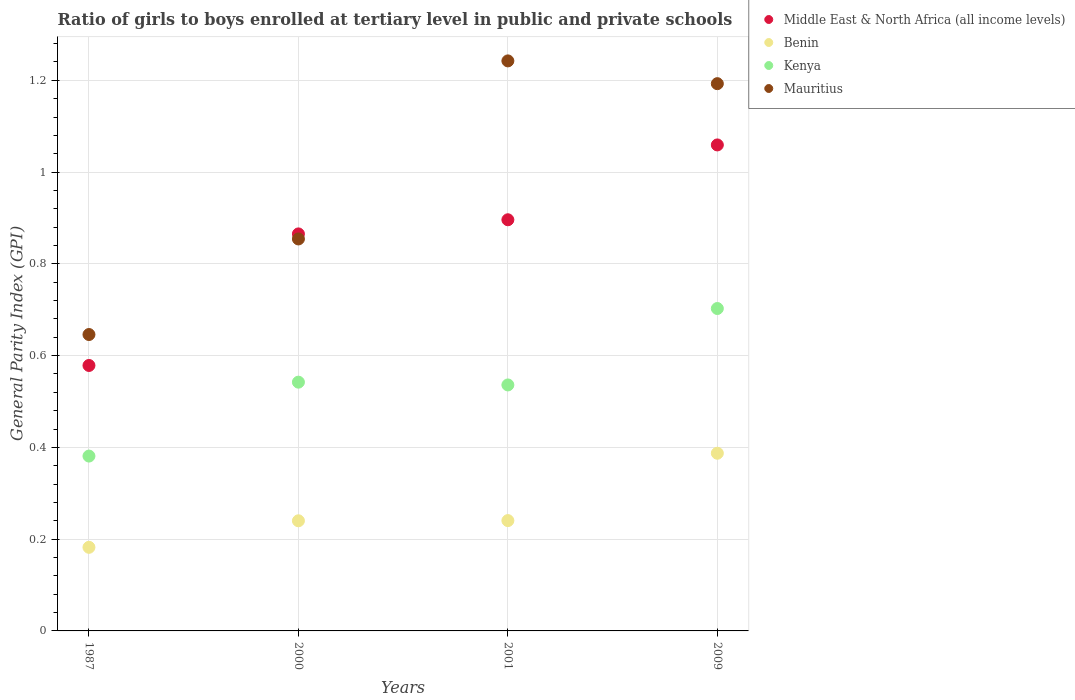How many different coloured dotlines are there?
Your response must be concise. 4. What is the general parity index in Kenya in 2001?
Give a very brief answer. 0.54. Across all years, what is the maximum general parity index in Kenya?
Make the answer very short. 0.7. Across all years, what is the minimum general parity index in Benin?
Keep it short and to the point. 0.18. In which year was the general parity index in Benin minimum?
Ensure brevity in your answer.  1987. What is the total general parity index in Middle East & North Africa (all income levels) in the graph?
Ensure brevity in your answer.  3.4. What is the difference between the general parity index in Kenya in 1987 and that in 2001?
Offer a terse response. -0.16. What is the difference between the general parity index in Benin in 1987 and the general parity index in Mauritius in 2009?
Ensure brevity in your answer.  -1.01. What is the average general parity index in Benin per year?
Make the answer very short. 0.26. In the year 2001, what is the difference between the general parity index in Mauritius and general parity index in Benin?
Offer a very short reply. 1. In how many years, is the general parity index in Middle East & North Africa (all income levels) greater than 1.2000000000000002?
Your answer should be compact. 0. What is the ratio of the general parity index in Middle East & North Africa (all income levels) in 2000 to that in 2001?
Make the answer very short. 0.97. Is the general parity index in Mauritius in 1987 less than that in 2001?
Ensure brevity in your answer.  Yes. What is the difference between the highest and the second highest general parity index in Middle East & North Africa (all income levels)?
Your answer should be compact. 0.16. What is the difference between the highest and the lowest general parity index in Benin?
Keep it short and to the point. 0.21. Is the sum of the general parity index in Middle East & North Africa (all income levels) in 2000 and 2009 greater than the maximum general parity index in Benin across all years?
Your answer should be very brief. Yes. Is it the case that in every year, the sum of the general parity index in Middle East & North Africa (all income levels) and general parity index in Kenya  is greater than the general parity index in Mauritius?
Make the answer very short. Yes. Is the general parity index in Mauritius strictly greater than the general parity index in Benin over the years?
Provide a short and direct response. Yes. How many dotlines are there?
Your answer should be very brief. 4. How many years are there in the graph?
Offer a very short reply. 4. What is the difference between two consecutive major ticks on the Y-axis?
Your answer should be very brief. 0.2. Are the values on the major ticks of Y-axis written in scientific E-notation?
Your response must be concise. No. Does the graph contain grids?
Provide a short and direct response. Yes. Where does the legend appear in the graph?
Give a very brief answer. Top right. How are the legend labels stacked?
Make the answer very short. Vertical. What is the title of the graph?
Provide a succinct answer. Ratio of girls to boys enrolled at tertiary level in public and private schools. Does "OECD members" appear as one of the legend labels in the graph?
Your response must be concise. No. What is the label or title of the Y-axis?
Your response must be concise. General Parity Index (GPI). What is the General Parity Index (GPI) of Middle East & North Africa (all income levels) in 1987?
Provide a succinct answer. 0.58. What is the General Parity Index (GPI) of Benin in 1987?
Make the answer very short. 0.18. What is the General Parity Index (GPI) in Kenya in 1987?
Your answer should be compact. 0.38. What is the General Parity Index (GPI) in Mauritius in 1987?
Offer a terse response. 0.65. What is the General Parity Index (GPI) of Middle East & North Africa (all income levels) in 2000?
Your answer should be very brief. 0.87. What is the General Parity Index (GPI) of Benin in 2000?
Your answer should be compact. 0.24. What is the General Parity Index (GPI) in Kenya in 2000?
Provide a short and direct response. 0.54. What is the General Parity Index (GPI) of Mauritius in 2000?
Provide a succinct answer. 0.85. What is the General Parity Index (GPI) of Middle East & North Africa (all income levels) in 2001?
Keep it short and to the point. 0.9. What is the General Parity Index (GPI) of Benin in 2001?
Your answer should be very brief. 0.24. What is the General Parity Index (GPI) in Kenya in 2001?
Offer a very short reply. 0.54. What is the General Parity Index (GPI) of Mauritius in 2001?
Offer a terse response. 1.24. What is the General Parity Index (GPI) of Middle East & North Africa (all income levels) in 2009?
Keep it short and to the point. 1.06. What is the General Parity Index (GPI) of Benin in 2009?
Provide a short and direct response. 0.39. What is the General Parity Index (GPI) in Kenya in 2009?
Provide a succinct answer. 0.7. What is the General Parity Index (GPI) in Mauritius in 2009?
Your answer should be compact. 1.19. Across all years, what is the maximum General Parity Index (GPI) in Middle East & North Africa (all income levels)?
Keep it short and to the point. 1.06. Across all years, what is the maximum General Parity Index (GPI) of Benin?
Ensure brevity in your answer.  0.39. Across all years, what is the maximum General Parity Index (GPI) in Kenya?
Your answer should be very brief. 0.7. Across all years, what is the maximum General Parity Index (GPI) in Mauritius?
Your answer should be very brief. 1.24. Across all years, what is the minimum General Parity Index (GPI) in Middle East & North Africa (all income levels)?
Provide a succinct answer. 0.58. Across all years, what is the minimum General Parity Index (GPI) of Benin?
Your answer should be compact. 0.18. Across all years, what is the minimum General Parity Index (GPI) in Kenya?
Give a very brief answer. 0.38. Across all years, what is the minimum General Parity Index (GPI) of Mauritius?
Your answer should be compact. 0.65. What is the total General Parity Index (GPI) of Middle East & North Africa (all income levels) in the graph?
Offer a terse response. 3.4. What is the total General Parity Index (GPI) in Benin in the graph?
Keep it short and to the point. 1.05. What is the total General Parity Index (GPI) in Kenya in the graph?
Give a very brief answer. 2.16. What is the total General Parity Index (GPI) of Mauritius in the graph?
Make the answer very short. 3.94. What is the difference between the General Parity Index (GPI) in Middle East & North Africa (all income levels) in 1987 and that in 2000?
Your answer should be compact. -0.29. What is the difference between the General Parity Index (GPI) of Benin in 1987 and that in 2000?
Make the answer very short. -0.06. What is the difference between the General Parity Index (GPI) in Kenya in 1987 and that in 2000?
Provide a succinct answer. -0.16. What is the difference between the General Parity Index (GPI) in Mauritius in 1987 and that in 2000?
Your answer should be compact. -0.21. What is the difference between the General Parity Index (GPI) of Middle East & North Africa (all income levels) in 1987 and that in 2001?
Give a very brief answer. -0.32. What is the difference between the General Parity Index (GPI) of Benin in 1987 and that in 2001?
Keep it short and to the point. -0.06. What is the difference between the General Parity Index (GPI) of Kenya in 1987 and that in 2001?
Ensure brevity in your answer.  -0.15. What is the difference between the General Parity Index (GPI) in Mauritius in 1987 and that in 2001?
Make the answer very short. -0.6. What is the difference between the General Parity Index (GPI) of Middle East & North Africa (all income levels) in 1987 and that in 2009?
Keep it short and to the point. -0.48. What is the difference between the General Parity Index (GPI) of Benin in 1987 and that in 2009?
Provide a short and direct response. -0.2. What is the difference between the General Parity Index (GPI) in Kenya in 1987 and that in 2009?
Your answer should be very brief. -0.32. What is the difference between the General Parity Index (GPI) of Mauritius in 1987 and that in 2009?
Offer a terse response. -0.55. What is the difference between the General Parity Index (GPI) of Middle East & North Africa (all income levels) in 2000 and that in 2001?
Offer a very short reply. -0.03. What is the difference between the General Parity Index (GPI) in Benin in 2000 and that in 2001?
Give a very brief answer. -0. What is the difference between the General Parity Index (GPI) in Kenya in 2000 and that in 2001?
Give a very brief answer. 0.01. What is the difference between the General Parity Index (GPI) in Mauritius in 2000 and that in 2001?
Provide a short and direct response. -0.39. What is the difference between the General Parity Index (GPI) in Middle East & North Africa (all income levels) in 2000 and that in 2009?
Give a very brief answer. -0.19. What is the difference between the General Parity Index (GPI) in Benin in 2000 and that in 2009?
Your answer should be very brief. -0.15. What is the difference between the General Parity Index (GPI) in Kenya in 2000 and that in 2009?
Give a very brief answer. -0.16. What is the difference between the General Parity Index (GPI) of Mauritius in 2000 and that in 2009?
Give a very brief answer. -0.34. What is the difference between the General Parity Index (GPI) of Middle East & North Africa (all income levels) in 2001 and that in 2009?
Your answer should be compact. -0.16. What is the difference between the General Parity Index (GPI) in Benin in 2001 and that in 2009?
Give a very brief answer. -0.15. What is the difference between the General Parity Index (GPI) in Kenya in 2001 and that in 2009?
Keep it short and to the point. -0.17. What is the difference between the General Parity Index (GPI) in Mauritius in 2001 and that in 2009?
Offer a terse response. 0.05. What is the difference between the General Parity Index (GPI) in Middle East & North Africa (all income levels) in 1987 and the General Parity Index (GPI) in Benin in 2000?
Give a very brief answer. 0.34. What is the difference between the General Parity Index (GPI) in Middle East & North Africa (all income levels) in 1987 and the General Parity Index (GPI) in Kenya in 2000?
Your answer should be very brief. 0.04. What is the difference between the General Parity Index (GPI) in Middle East & North Africa (all income levels) in 1987 and the General Parity Index (GPI) in Mauritius in 2000?
Offer a very short reply. -0.28. What is the difference between the General Parity Index (GPI) of Benin in 1987 and the General Parity Index (GPI) of Kenya in 2000?
Your response must be concise. -0.36. What is the difference between the General Parity Index (GPI) in Benin in 1987 and the General Parity Index (GPI) in Mauritius in 2000?
Your answer should be very brief. -0.67. What is the difference between the General Parity Index (GPI) of Kenya in 1987 and the General Parity Index (GPI) of Mauritius in 2000?
Your answer should be very brief. -0.47. What is the difference between the General Parity Index (GPI) in Middle East & North Africa (all income levels) in 1987 and the General Parity Index (GPI) in Benin in 2001?
Ensure brevity in your answer.  0.34. What is the difference between the General Parity Index (GPI) in Middle East & North Africa (all income levels) in 1987 and the General Parity Index (GPI) in Kenya in 2001?
Keep it short and to the point. 0.04. What is the difference between the General Parity Index (GPI) of Middle East & North Africa (all income levels) in 1987 and the General Parity Index (GPI) of Mauritius in 2001?
Provide a short and direct response. -0.66. What is the difference between the General Parity Index (GPI) in Benin in 1987 and the General Parity Index (GPI) in Kenya in 2001?
Provide a short and direct response. -0.35. What is the difference between the General Parity Index (GPI) in Benin in 1987 and the General Parity Index (GPI) in Mauritius in 2001?
Offer a very short reply. -1.06. What is the difference between the General Parity Index (GPI) in Kenya in 1987 and the General Parity Index (GPI) in Mauritius in 2001?
Your answer should be very brief. -0.86. What is the difference between the General Parity Index (GPI) in Middle East & North Africa (all income levels) in 1987 and the General Parity Index (GPI) in Benin in 2009?
Your answer should be very brief. 0.19. What is the difference between the General Parity Index (GPI) of Middle East & North Africa (all income levels) in 1987 and the General Parity Index (GPI) of Kenya in 2009?
Give a very brief answer. -0.12. What is the difference between the General Parity Index (GPI) in Middle East & North Africa (all income levels) in 1987 and the General Parity Index (GPI) in Mauritius in 2009?
Offer a very short reply. -0.61. What is the difference between the General Parity Index (GPI) in Benin in 1987 and the General Parity Index (GPI) in Kenya in 2009?
Offer a very short reply. -0.52. What is the difference between the General Parity Index (GPI) in Benin in 1987 and the General Parity Index (GPI) in Mauritius in 2009?
Your response must be concise. -1.01. What is the difference between the General Parity Index (GPI) of Kenya in 1987 and the General Parity Index (GPI) of Mauritius in 2009?
Give a very brief answer. -0.81. What is the difference between the General Parity Index (GPI) of Middle East & North Africa (all income levels) in 2000 and the General Parity Index (GPI) of Benin in 2001?
Ensure brevity in your answer.  0.62. What is the difference between the General Parity Index (GPI) of Middle East & North Africa (all income levels) in 2000 and the General Parity Index (GPI) of Kenya in 2001?
Your answer should be compact. 0.33. What is the difference between the General Parity Index (GPI) in Middle East & North Africa (all income levels) in 2000 and the General Parity Index (GPI) in Mauritius in 2001?
Keep it short and to the point. -0.38. What is the difference between the General Parity Index (GPI) of Benin in 2000 and the General Parity Index (GPI) of Kenya in 2001?
Your response must be concise. -0.3. What is the difference between the General Parity Index (GPI) in Benin in 2000 and the General Parity Index (GPI) in Mauritius in 2001?
Offer a very short reply. -1. What is the difference between the General Parity Index (GPI) of Kenya in 2000 and the General Parity Index (GPI) of Mauritius in 2001?
Your response must be concise. -0.7. What is the difference between the General Parity Index (GPI) in Middle East & North Africa (all income levels) in 2000 and the General Parity Index (GPI) in Benin in 2009?
Your answer should be compact. 0.48. What is the difference between the General Parity Index (GPI) of Middle East & North Africa (all income levels) in 2000 and the General Parity Index (GPI) of Kenya in 2009?
Offer a very short reply. 0.16. What is the difference between the General Parity Index (GPI) in Middle East & North Africa (all income levels) in 2000 and the General Parity Index (GPI) in Mauritius in 2009?
Keep it short and to the point. -0.33. What is the difference between the General Parity Index (GPI) in Benin in 2000 and the General Parity Index (GPI) in Kenya in 2009?
Offer a terse response. -0.46. What is the difference between the General Parity Index (GPI) of Benin in 2000 and the General Parity Index (GPI) of Mauritius in 2009?
Offer a terse response. -0.95. What is the difference between the General Parity Index (GPI) in Kenya in 2000 and the General Parity Index (GPI) in Mauritius in 2009?
Make the answer very short. -0.65. What is the difference between the General Parity Index (GPI) of Middle East & North Africa (all income levels) in 2001 and the General Parity Index (GPI) of Benin in 2009?
Give a very brief answer. 0.51. What is the difference between the General Parity Index (GPI) of Middle East & North Africa (all income levels) in 2001 and the General Parity Index (GPI) of Kenya in 2009?
Your answer should be very brief. 0.19. What is the difference between the General Parity Index (GPI) in Middle East & North Africa (all income levels) in 2001 and the General Parity Index (GPI) in Mauritius in 2009?
Ensure brevity in your answer.  -0.3. What is the difference between the General Parity Index (GPI) of Benin in 2001 and the General Parity Index (GPI) of Kenya in 2009?
Provide a succinct answer. -0.46. What is the difference between the General Parity Index (GPI) in Benin in 2001 and the General Parity Index (GPI) in Mauritius in 2009?
Provide a short and direct response. -0.95. What is the difference between the General Parity Index (GPI) in Kenya in 2001 and the General Parity Index (GPI) in Mauritius in 2009?
Your response must be concise. -0.66. What is the average General Parity Index (GPI) of Middle East & North Africa (all income levels) per year?
Give a very brief answer. 0.85. What is the average General Parity Index (GPI) in Benin per year?
Your response must be concise. 0.26. What is the average General Parity Index (GPI) of Kenya per year?
Your answer should be compact. 0.54. What is the average General Parity Index (GPI) of Mauritius per year?
Offer a very short reply. 0.98. In the year 1987, what is the difference between the General Parity Index (GPI) of Middle East & North Africa (all income levels) and General Parity Index (GPI) of Benin?
Provide a short and direct response. 0.4. In the year 1987, what is the difference between the General Parity Index (GPI) of Middle East & North Africa (all income levels) and General Parity Index (GPI) of Kenya?
Ensure brevity in your answer.  0.2. In the year 1987, what is the difference between the General Parity Index (GPI) in Middle East & North Africa (all income levels) and General Parity Index (GPI) in Mauritius?
Provide a short and direct response. -0.07. In the year 1987, what is the difference between the General Parity Index (GPI) of Benin and General Parity Index (GPI) of Kenya?
Make the answer very short. -0.2. In the year 1987, what is the difference between the General Parity Index (GPI) of Benin and General Parity Index (GPI) of Mauritius?
Your answer should be very brief. -0.46. In the year 1987, what is the difference between the General Parity Index (GPI) in Kenya and General Parity Index (GPI) in Mauritius?
Offer a terse response. -0.26. In the year 2000, what is the difference between the General Parity Index (GPI) in Middle East & North Africa (all income levels) and General Parity Index (GPI) in Benin?
Offer a terse response. 0.63. In the year 2000, what is the difference between the General Parity Index (GPI) in Middle East & North Africa (all income levels) and General Parity Index (GPI) in Kenya?
Ensure brevity in your answer.  0.32. In the year 2000, what is the difference between the General Parity Index (GPI) in Middle East & North Africa (all income levels) and General Parity Index (GPI) in Mauritius?
Offer a very short reply. 0.01. In the year 2000, what is the difference between the General Parity Index (GPI) in Benin and General Parity Index (GPI) in Kenya?
Offer a very short reply. -0.3. In the year 2000, what is the difference between the General Parity Index (GPI) in Benin and General Parity Index (GPI) in Mauritius?
Give a very brief answer. -0.61. In the year 2000, what is the difference between the General Parity Index (GPI) in Kenya and General Parity Index (GPI) in Mauritius?
Keep it short and to the point. -0.31. In the year 2001, what is the difference between the General Parity Index (GPI) of Middle East & North Africa (all income levels) and General Parity Index (GPI) of Benin?
Your answer should be very brief. 0.66. In the year 2001, what is the difference between the General Parity Index (GPI) in Middle East & North Africa (all income levels) and General Parity Index (GPI) in Kenya?
Ensure brevity in your answer.  0.36. In the year 2001, what is the difference between the General Parity Index (GPI) in Middle East & North Africa (all income levels) and General Parity Index (GPI) in Mauritius?
Offer a terse response. -0.35. In the year 2001, what is the difference between the General Parity Index (GPI) of Benin and General Parity Index (GPI) of Kenya?
Your answer should be very brief. -0.3. In the year 2001, what is the difference between the General Parity Index (GPI) in Benin and General Parity Index (GPI) in Mauritius?
Keep it short and to the point. -1. In the year 2001, what is the difference between the General Parity Index (GPI) in Kenya and General Parity Index (GPI) in Mauritius?
Make the answer very short. -0.71. In the year 2009, what is the difference between the General Parity Index (GPI) of Middle East & North Africa (all income levels) and General Parity Index (GPI) of Benin?
Make the answer very short. 0.67. In the year 2009, what is the difference between the General Parity Index (GPI) of Middle East & North Africa (all income levels) and General Parity Index (GPI) of Kenya?
Make the answer very short. 0.36. In the year 2009, what is the difference between the General Parity Index (GPI) of Middle East & North Africa (all income levels) and General Parity Index (GPI) of Mauritius?
Keep it short and to the point. -0.13. In the year 2009, what is the difference between the General Parity Index (GPI) in Benin and General Parity Index (GPI) in Kenya?
Provide a succinct answer. -0.32. In the year 2009, what is the difference between the General Parity Index (GPI) in Benin and General Parity Index (GPI) in Mauritius?
Provide a succinct answer. -0.81. In the year 2009, what is the difference between the General Parity Index (GPI) in Kenya and General Parity Index (GPI) in Mauritius?
Your answer should be compact. -0.49. What is the ratio of the General Parity Index (GPI) of Middle East & North Africa (all income levels) in 1987 to that in 2000?
Make the answer very short. 0.67. What is the ratio of the General Parity Index (GPI) of Benin in 1987 to that in 2000?
Provide a succinct answer. 0.76. What is the ratio of the General Parity Index (GPI) in Kenya in 1987 to that in 2000?
Give a very brief answer. 0.7. What is the ratio of the General Parity Index (GPI) in Mauritius in 1987 to that in 2000?
Keep it short and to the point. 0.76. What is the ratio of the General Parity Index (GPI) of Middle East & North Africa (all income levels) in 1987 to that in 2001?
Keep it short and to the point. 0.65. What is the ratio of the General Parity Index (GPI) of Benin in 1987 to that in 2001?
Your answer should be compact. 0.76. What is the ratio of the General Parity Index (GPI) in Kenya in 1987 to that in 2001?
Your response must be concise. 0.71. What is the ratio of the General Parity Index (GPI) in Mauritius in 1987 to that in 2001?
Make the answer very short. 0.52. What is the ratio of the General Parity Index (GPI) in Middle East & North Africa (all income levels) in 1987 to that in 2009?
Your response must be concise. 0.55. What is the ratio of the General Parity Index (GPI) of Benin in 1987 to that in 2009?
Offer a terse response. 0.47. What is the ratio of the General Parity Index (GPI) in Kenya in 1987 to that in 2009?
Provide a succinct answer. 0.54. What is the ratio of the General Parity Index (GPI) of Mauritius in 1987 to that in 2009?
Offer a very short reply. 0.54. What is the ratio of the General Parity Index (GPI) of Middle East & North Africa (all income levels) in 2000 to that in 2001?
Make the answer very short. 0.97. What is the ratio of the General Parity Index (GPI) of Kenya in 2000 to that in 2001?
Your answer should be compact. 1.01. What is the ratio of the General Parity Index (GPI) in Mauritius in 2000 to that in 2001?
Provide a short and direct response. 0.69. What is the ratio of the General Parity Index (GPI) in Middle East & North Africa (all income levels) in 2000 to that in 2009?
Ensure brevity in your answer.  0.82. What is the ratio of the General Parity Index (GPI) of Benin in 2000 to that in 2009?
Your answer should be very brief. 0.62. What is the ratio of the General Parity Index (GPI) of Kenya in 2000 to that in 2009?
Make the answer very short. 0.77. What is the ratio of the General Parity Index (GPI) in Mauritius in 2000 to that in 2009?
Your answer should be very brief. 0.72. What is the ratio of the General Parity Index (GPI) in Middle East & North Africa (all income levels) in 2001 to that in 2009?
Provide a short and direct response. 0.85. What is the ratio of the General Parity Index (GPI) of Benin in 2001 to that in 2009?
Offer a very short reply. 0.62. What is the ratio of the General Parity Index (GPI) of Kenya in 2001 to that in 2009?
Provide a succinct answer. 0.76. What is the ratio of the General Parity Index (GPI) in Mauritius in 2001 to that in 2009?
Provide a succinct answer. 1.04. What is the difference between the highest and the second highest General Parity Index (GPI) of Middle East & North Africa (all income levels)?
Give a very brief answer. 0.16. What is the difference between the highest and the second highest General Parity Index (GPI) of Benin?
Ensure brevity in your answer.  0.15. What is the difference between the highest and the second highest General Parity Index (GPI) in Kenya?
Your response must be concise. 0.16. What is the difference between the highest and the second highest General Parity Index (GPI) of Mauritius?
Offer a terse response. 0.05. What is the difference between the highest and the lowest General Parity Index (GPI) in Middle East & North Africa (all income levels)?
Your response must be concise. 0.48. What is the difference between the highest and the lowest General Parity Index (GPI) in Benin?
Your response must be concise. 0.2. What is the difference between the highest and the lowest General Parity Index (GPI) in Kenya?
Your answer should be very brief. 0.32. What is the difference between the highest and the lowest General Parity Index (GPI) in Mauritius?
Make the answer very short. 0.6. 